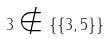<formula> <loc_0><loc_0><loc_500><loc_500>3 \notin \{ \{ 3 , 5 \} \}</formula> 